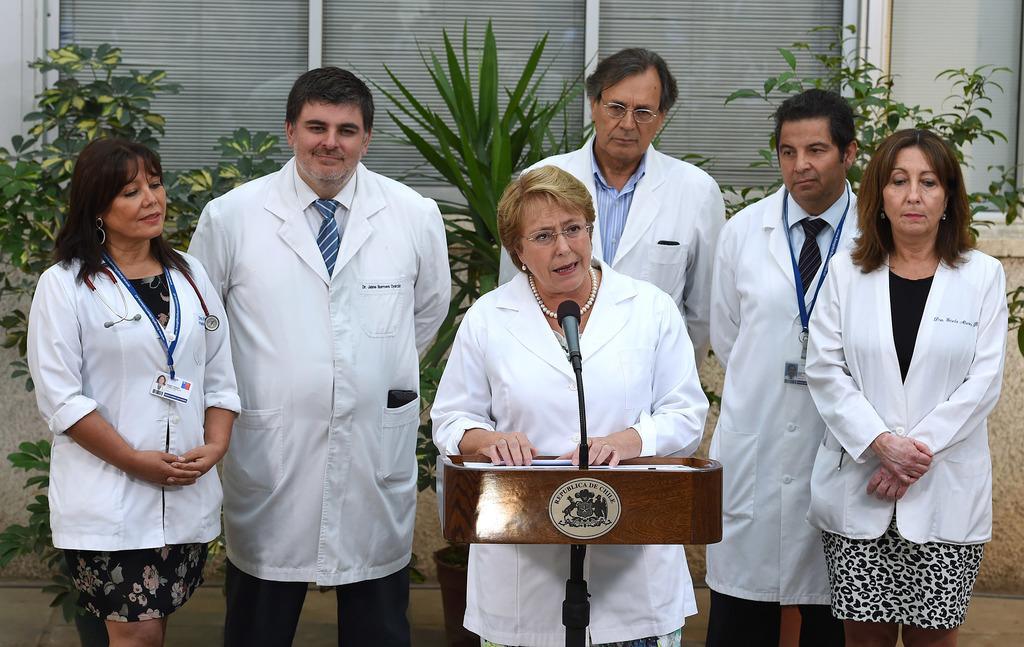Describe this image in one or two sentences. In this picture I can see there are a group of people standing and they are wearing aprons and one of them is speaking and in the backdrop there are plants, windows and there is a wall. 